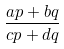Convert formula to latex. <formula><loc_0><loc_0><loc_500><loc_500>\frac { a p + b q } { c p + d q }</formula> 